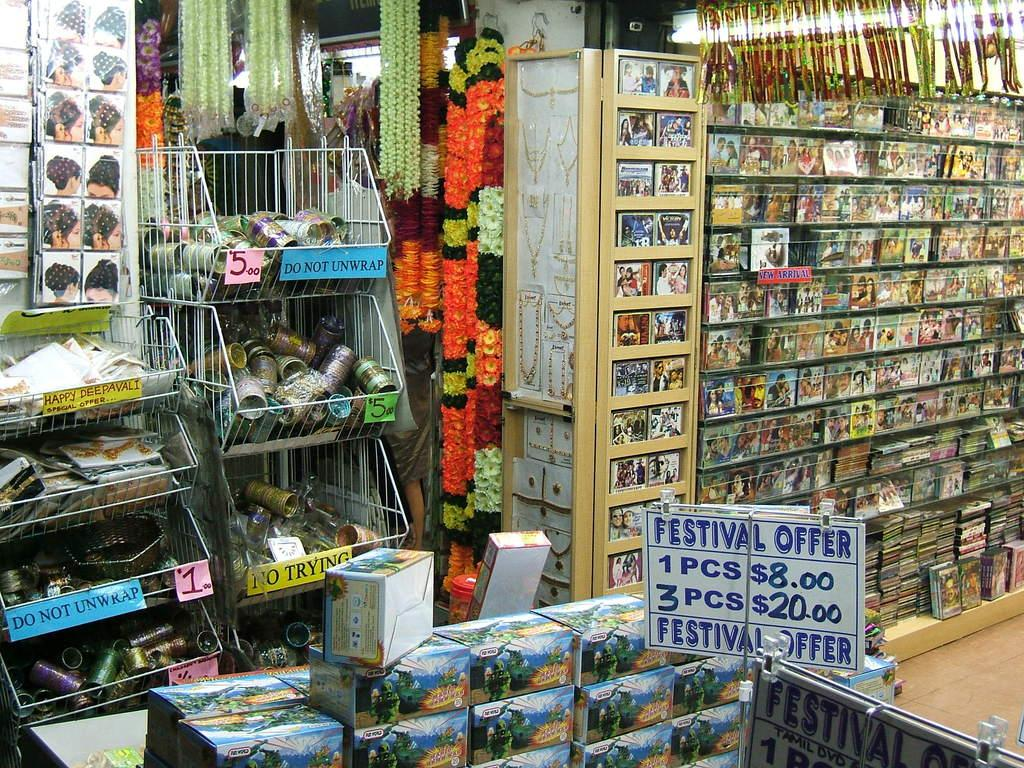<image>
Describe the image concisely. A store with many items that is advertising a special Festival Offer. 